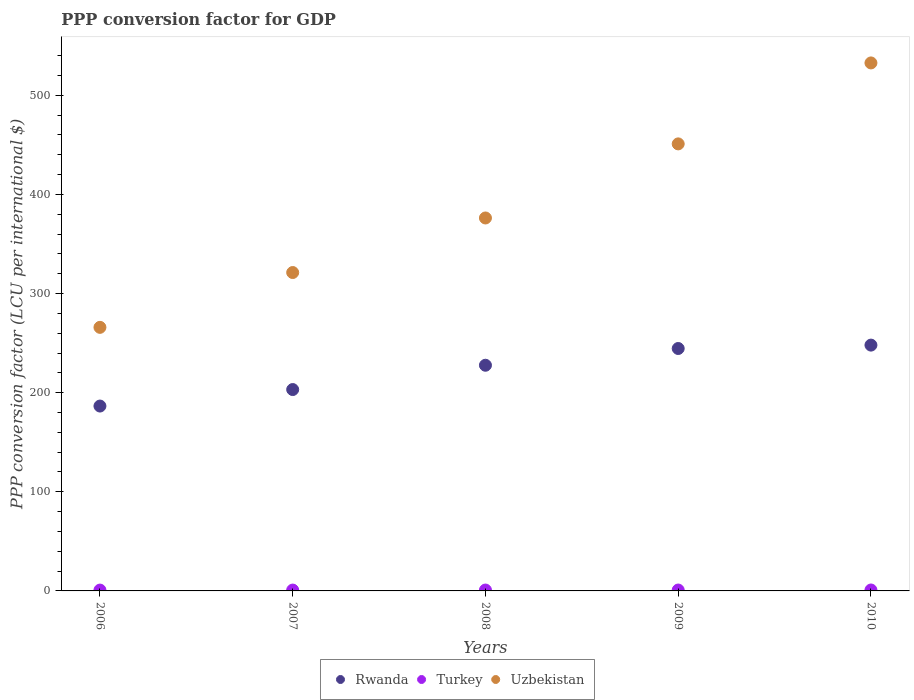How many different coloured dotlines are there?
Your answer should be compact. 3. What is the PPP conversion factor for GDP in Uzbekistan in 2007?
Keep it short and to the point. 321.22. Across all years, what is the maximum PPP conversion factor for GDP in Rwanda?
Keep it short and to the point. 248. Across all years, what is the minimum PPP conversion factor for GDP in Rwanda?
Ensure brevity in your answer.  186.52. In which year was the PPP conversion factor for GDP in Uzbekistan minimum?
Keep it short and to the point. 2006. What is the total PPP conversion factor for GDP in Turkey in the graph?
Make the answer very short. 4.45. What is the difference between the PPP conversion factor for GDP in Uzbekistan in 2007 and that in 2010?
Keep it short and to the point. -211.46. What is the difference between the PPP conversion factor for GDP in Uzbekistan in 2007 and the PPP conversion factor for GDP in Turkey in 2009?
Your answer should be very brief. 320.31. What is the average PPP conversion factor for GDP in Rwanda per year?
Offer a terse response. 221.99. In the year 2010, what is the difference between the PPP conversion factor for GDP in Rwanda and PPP conversion factor for GDP in Uzbekistan?
Your answer should be very brief. -284.69. What is the ratio of the PPP conversion factor for GDP in Rwanda in 2006 to that in 2008?
Offer a terse response. 0.82. Is the PPP conversion factor for GDP in Uzbekistan in 2006 less than that in 2008?
Your response must be concise. Yes. Is the difference between the PPP conversion factor for GDP in Rwanda in 2006 and 2008 greater than the difference between the PPP conversion factor for GDP in Uzbekistan in 2006 and 2008?
Provide a succinct answer. Yes. What is the difference between the highest and the second highest PPP conversion factor for GDP in Rwanda?
Your response must be concise. 3.42. What is the difference between the highest and the lowest PPP conversion factor for GDP in Uzbekistan?
Provide a succinct answer. 266.77. In how many years, is the PPP conversion factor for GDP in Turkey greater than the average PPP conversion factor for GDP in Turkey taken over all years?
Offer a terse response. 2. Is the PPP conversion factor for GDP in Uzbekistan strictly less than the PPP conversion factor for GDP in Turkey over the years?
Make the answer very short. No. How many dotlines are there?
Provide a succinct answer. 3. Are the values on the major ticks of Y-axis written in scientific E-notation?
Your answer should be very brief. No. Does the graph contain grids?
Your answer should be very brief. No. Where does the legend appear in the graph?
Provide a succinct answer. Bottom center. How many legend labels are there?
Your response must be concise. 3. How are the legend labels stacked?
Offer a very short reply. Horizontal. What is the title of the graph?
Your response must be concise. PPP conversion factor for GDP. What is the label or title of the X-axis?
Provide a short and direct response. Years. What is the label or title of the Y-axis?
Your answer should be compact. PPP conversion factor (LCU per international $). What is the PPP conversion factor (LCU per international $) of Rwanda in 2006?
Provide a succinct answer. 186.52. What is the PPP conversion factor (LCU per international $) of Turkey in 2006?
Make the answer very short. 0.85. What is the PPP conversion factor (LCU per international $) in Uzbekistan in 2006?
Your answer should be compact. 265.92. What is the PPP conversion factor (LCU per international $) in Rwanda in 2007?
Keep it short and to the point. 203.16. What is the PPP conversion factor (LCU per international $) of Turkey in 2007?
Offer a terse response. 0.86. What is the PPP conversion factor (LCU per international $) in Uzbekistan in 2007?
Offer a terse response. 321.22. What is the PPP conversion factor (LCU per international $) of Rwanda in 2008?
Your answer should be very brief. 227.68. What is the PPP conversion factor (LCU per international $) in Turkey in 2008?
Offer a terse response. 0.89. What is the PPP conversion factor (LCU per international $) in Uzbekistan in 2008?
Give a very brief answer. 376.27. What is the PPP conversion factor (LCU per international $) of Rwanda in 2009?
Provide a succinct answer. 244.58. What is the PPP conversion factor (LCU per international $) of Turkey in 2009?
Offer a terse response. 0.91. What is the PPP conversion factor (LCU per international $) of Uzbekistan in 2009?
Provide a short and direct response. 451.01. What is the PPP conversion factor (LCU per international $) of Rwanda in 2010?
Your answer should be compact. 248. What is the PPP conversion factor (LCU per international $) of Turkey in 2010?
Make the answer very short. 0.94. What is the PPP conversion factor (LCU per international $) in Uzbekistan in 2010?
Give a very brief answer. 532.69. Across all years, what is the maximum PPP conversion factor (LCU per international $) of Rwanda?
Offer a terse response. 248. Across all years, what is the maximum PPP conversion factor (LCU per international $) of Turkey?
Provide a short and direct response. 0.94. Across all years, what is the maximum PPP conversion factor (LCU per international $) of Uzbekistan?
Your answer should be very brief. 532.69. Across all years, what is the minimum PPP conversion factor (LCU per international $) of Rwanda?
Make the answer very short. 186.52. Across all years, what is the minimum PPP conversion factor (LCU per international $) in Turkey?
Give a very brief answer. 0.85. Across all years, what is the minimum PPP conversion factor (LCU per international $) of Uzbekistan?
Give a very brief answer. 265.92. What is the total PPP conversion factor (LCU per international $) of Rwanda in the graph?
Make the answer very short. 1109.94. What is the total PPP conversion factor (LCU per international $) in Turkey in the graph?
Provide a succinct answer. 4.45. What is the total PPP conversion factor (LCU per international $) of Uzbekistan in the graph?
Ensure brevity in your answer.  1947.11. What is the difference between the PPP conversion factor (LCU per international $) in Rwanda in 2006 and that in 2007?
Ensure brevity in your answer.  -16.65. What is the difference between the PPP conversion factor (LCU per international $) of Turkey in 2006 and that in 2007?
Keep it short and to the point. -0.02. What is the difference between the PPP conversion factor (LCU per international $) of Uzbekistan in 2006 and that in 2007?
Make the answer very short. -55.31. What is the difference between the PPP conversion factor (LCU per international $) in Rwanda in 2006 and that in 2008?
Your response must be concise. -41.17. What is the difference between the PPP conversion factor (LCU per international $) in Turkey in 2006 and that in 2008?
Offer a very short reply. -0.04. What is the difference between the PPP conversion factor (LCU per international $) in Uzbekistan in 2006 and that in 2008?
Your response must be concise. -110.35. What is the difference between the PPP conversion factor (LCU per international $) of Rwanda in 2006 and that in 2009?
Make the answer very short. -58.06. What is the difference between the PPP conversion factor (LCU per international $) in Turkey in 2006 and that in 2009?
Your response must be concise. -0.07. What is the difference between the PPP conversion factor (LCU per international $) in Uzbekistan in 2006 and that in 2009?
Your response must be concise. -185.1. What is the difference between the PPP conversion factor (LCU per international $) in Rwanda in 2006 and that in 2010?
Provide a short and direct response. -61.48. What is the difference between the PPP conversion factor (LCU per international $) in Turkey in 2006 and that in 2010?
Your response must be concise. -0.09. What is the difference between the PPP conversion factor (LCU per international $) of Uzbekistan in 2006 and that in 2010?
Offer a terse response. -266.77. What is the difference between the PPP conversion factor (LCU per international $) in Rwanda in 2007 and that in 2008?
Your answer should be very brief. -24.52. What is the difference between the PPP conversion factor (LCU per international $) in Turkey in 2007 and that in 2008?
Offer a very short reply. -0.03. What is the difference between the PPP conversion factor (LCU per international $) in Uzbekistan in 2007 and that in 2008?
Provide a short and direct response. -55.04. What is the difference between the PPP conversion factor (LCU per international $) of Rwanda in 2007 and that in 2009?
Provide a short and direct response. -41.41. What is the difference between the PPP conversion factor (LCU per international $) in Turkey in 2007 and that in 2009?
Your answer should be very brief. -0.05. What is the difference between the PPP conversion factor (LCU per international $) in Uzbekistan in 2007 and that in 2009?
Offer a terse response. -129.79. What is the difference between the PPP conversion factor (LCU per international $) in Rwanda in 2007 and that in 2010?
Give a very brief answer. -44.84. What is the difference between the PPP conversion factor (LCU per international $) in Turkey in 2007 and that in 2010?
Your response must be concise. -0.08. What is the difference between the PPP conversion factor (LCU per international $) in Uzbekistan in 2007 and that in 2010?
Offer a very short reply. -211.46. What is the difference between the PPP conversion factor (LCU per international $) in Rwanda in 2008 and that in 2009?
Ensure brevity in your answer.  -16.9. What is the difference between the PPP conversion factor (LCU per international $) of Turkey in 2008 and that in 2009?
Your response must be concise. -0.02. What is the difference between the PPP conversion factor (LCU per international $) of Uzbekistan in 2008 and that in 2009?
Your response must be concise. -74.75. What is the difference between the PPP conversion factor (LCU per international $) of Rwanda in 2008 and that in 2010?
Give a very brief answer. -20.32. What is the difference between the PPP conversion factor (LCU per international $) of Turkey in 2008 and that in 2010?
Your answer should be very brief. -0.05. What is the difference between the PPP conversion factor (LCU per international $) in Uzbekistan in 2008 and that in 2010?
Keep it short and to the point. -156.42. What is the difference between the PPP conversion factor (LCU per international $) in Rwanda in 2009 and that in 2010?
Offer a very short reply. -3.42. What is the difference between the PPP conversion factor (LCU per international $) in Turkey in 2009 and that in 2010?
Offer a very short reply. -0.03. What is the difference between the PPP conversion factor (LCU per international $) in Uzbekistan in 2009 and that in 2010?
Make the answer very short. -81.67. What is the difference between the PPP conversion factor (LCU per international $) of Rwanda in 2006 and the PPP conversion factor (LCU per international $) of Turkey in 2007?
Make the answer very short. 185.65. What is the difference between the PPP conversion factor (LCU per international $) in Rwanda in 2006 and the PPP conversion factor (LCU per international $) in Uzbekistan in 2007?
Offer a terse response. -134.71. What is the difference between the PPP conversion factor (LCU per international $) of Turkey in 2006 and the PPP conversion factor (LCU per international $) of Uzbekistan in 2007?
Ensure brevity in your answer.  -320.38. What is the difference between the PPP conversion factor (LCU per international $) in Rwanda in 2006 and the PPP conversion factor (LCU per international $) in Turkey in 2008?
Offer a terse response. 185.63. What is the difference between the PPP conversion factor (LCU per international $) of Rwanda in 2006 and the PPP conversion factor (LCU per international $) of Uzbekistan in 2008?
Make the answer very short. -189.75. What is the difference between the PPP conversion factor (LCU per international $) in Turkey in 2006 and the PPP conversion factor (LCU per international $) in Uzbekistan in 2008?
Your answer should be very brief. -375.42. What is the difference between the PPP conversion factor (LCU per international $) of Rwanda in 2006 and the PPP conversion factor (LCU per international $) of Turkey in 2009?
Make the answer very short. 185.6. What is the difference between the PPP conversion factor (LCU per international $) of Rwanda in 2006 and the PPP conversion factor (LCU per international $) of Uzbekistan in 2009?
Offer a very short reply. -264.5. What is the difference between the PPP conversion factor (LCU per international $) of Turkey in 2006 and the PPP conversion factor (LCU per international $) of Uzbekistan in 2009?
Provide a short and direct response. -450.17. What is the difference between the PPP conversion factor (LCU per international $) in Rwanda in 2006 and the PPP conversion factor (LCU per international $) in Turkey in 2010?
Offer a terse response. 185.57. What is the difference between the PPP conversion factor (LCU per international $) in Rwanda in 2006 and the PPP conversion factor (LCU per international $) in Uzbekistan in 2010?
Your answer should be compact. -346.17. What is the difference between the PPP conversion factor (LCU per international $) of Turkey in 2006 and the PPP conversion factor (LCU per international $) of Uzbekistan in 2010?
Ensure brevity in your answer.  -531.84. What is the difference between the PPP conversion factor (LCU per international $) of Rwanda in 2007 and the PPP conversion factor (LCU per international $) of Turkey in 2008?
Provide a short and direct response. 202.27. What is the difference between the PPP conversion factor (LCU per international $) of Rwanda in 2007 and the PPP conversion factor (LCU per international $) of Uzbekistan in 2008?
Offer a terse response. -173.1. What is the difference between the PPP conversion factor (LCU per international $) of Turkey in 2007 and the PPP conversion factor (LCU per international $) of Uzbekistan in 2008?
Your answer should be compact. -375.4. What is the difference between the PPP conversion factor (LCU per international $) in Rwanda in 2007 and the PPP conversion factor (LCU per international $) in Turkey in 2009?
Offer a very short reply. 202.25. What is the difference between the PPP conversion factor (LCU per international $) of Rwanda in 2007 and the PPP conversion factor (LCU per international $) of Uzbekistan in 2009?
Keep it short and to the point. -247.85. What is the difference between the PPP conversion factor (LCU per international $) in Turkey in 2007 and the PPP conversion factor (LCU per international $) in Uzbekistan in 2009?
Your answer should be very brief. -450.15. What is the difference between the PPP conversion factor (LCU per international $) in Rwanda in 2007 and the PPP conversion factor (LCU per international $) in Turkey in 2010?
Offer a very short reply. 202.22. What is the difference between the PPP conversion factor (LCU per international $) of Rwanda in 2007 and the PPP conversion factor (LCU per international $) of Uzbekistan in 2010?
Offer a very short reply. -329.52. What is the difference between the PPP conversion factor (LCU per international $) in Turkey in 2007 and the PPP conversion factor (LCU per international $) in Uzbekistan in 2010?
Give a very brief answer. -531.82. What is the difference between the PPP conversion factor (LCU per international $) of Rwanda in 2008 and the PPP conversion factor (LCU per international $) of Turkey in 2009?
Give a very brief answer. 226.77. What is the difference between the PPP conversion factor (LCU per international $) in Rwanda in 2008 and the PPP conversion factor (LCU per international $) in Uzbekistan in 2009?
Give a very brief answer. -223.33. What is the difference between the PPP conversion factor (LCU per international $) of Turkey in 2008 and the PPP conversion factor (LCU per international $) of Uzbekistan in 2009?
Provide a short and direct response. -450.12. What is the difference between the PPP conversion factor (LCU per international $) of Rwanda in 2008 and the PPP conversion factor (LCU per international $) of Turkey in 2010?
Your response must be concise. 226.74. What is the difference between the PPP conversion factor (LCU per international $) in Rwanda in 2008 and the PPP conversion factor (LCU per international $) in Uzbekistan in 2010?
Make the answer very short. -305.01. What is the difference between the PPP conversion factor (LCU per international $) in Turkey in 2008 and the PPP conversion factor (LCU per international $) in Uzbekistan in 2010?
Your response must be concise. -531.8. What is the difference between the PPP conversion factor (LCU per international $) of Rwanda in 2009 and the PPP conversion factor (LCU per international $) of Turkey in 2010?
Your answer should be very brief. 243.64. What is the difference between the PPP conversion factor (LCU per international $) in Rwanda in 2009 and the PPP conversion factor (LCU per international $) in Uzbekistan in 2010?
Offer a terse response. -288.11. What is the difference between the PPP conversion factor (LCU per international $) in Turkey in 2009 and the PPP conversion factor (LCU per international $) in Uzbekistan in 2010?
Your answer should be compact. -531.78. What is the average PPP conversion factor (LCU per international $) of Rwanda per year?
Make the answer very short. 221.99. What is the average PPP conversion factor (LCU per international $) in Turkey per year?
Offer a very short reply. 0.89. What is the average PPP conversion factor (LCU per international $) in Uzbekistan per year?
Keep it short and to the point. 389.42. In the year 2006, what is the difference between the PPP conversion factor (LCU per international $) of Rwanda and PPP conversion factor (LCU per international $) of Turkey?
Offer a terse response. 185.67. In the year 2006, what is the difference between the PPP conversion factor (LCU per international $) of Rwanda and PPP conversion factor (LCU per international $) of Uzbekistan?
Keep it short and to the point. -79.4. In the year 2006, what is the difference between the PPP conversion factor (LCU per international $) of Turkey and PPP conversion factor (LCU per international $) of Uzbekistan?
Offer a terse response. -265.07. In the year 2007, what is the difference between the PPP conversion factor (LCU per international $) in Rwanda and PPP conversion factor (LCU per international $) in Turkey?
Your answer should be very brief. 202.3. In the year 2007, what is the difference between the PPP conversion factor (LCU per international $) in Rwanda and PPP conversion factor (LCU per international $) in Uzbekistan?
Give a very brief answer. -118.06. In the year 2007, what is the difference between the PPP conversion factor (LCU per international $) of Turkey and PPP conversion factor (LCU per international $) of Uzbekistan?
Your answer should be very brief. -320.36. In the year 2008, what is the difference between the PPP conversion factor (LCU per international $) of Rwanda and PPP conversion factor (LCU per international $) of Turkey?
Ensure brevity in your answer.  226.79. In the year 2008, what is the difference between the PPP conversion factor (LCU per international $) of Rwanda and PPP conversion factor (LCU per international $) of Uzbekistan?
Provide a short and direct response. -148.58. In the year 2008, what is the difference between the PPP conversion factor (LCU per international $) of Turkey and PPP conversion factor (LCU per international $) of Uzbekistan?
Your answer should be compact. -375.38. In the year 2009, what is the difference between the PPP conversion factor (LCU per international $) of Rwanda and PPP conversion factor (LCU per international $) of Turkey?
Provide a short and direct response. 243.67. In the year 2009, what is the difference between the PPP conversion factor (LCU per international $) of Rwanda and PPP conversion factor (LCU per international $) of Uzbekistan?
Your answer should be very brief. -206.44. In the year 2009, what is the difference between the PPP conversion factor (LCU per international $) in Turkey and PPP conversion factor (LCU per international $) in Uzbekistan?
Your answer should be compact. -450.1. In the year 2010, what is the difference between the PPP conversion factor (LCU per international $) in Rwanda and PPP conversion factor (LCU per international $) in Turkey?
Make the answer very short. 247.06. In the year 2010, what is the difference between the PPP conversion factor (LCU per international $) in Rwanda and PPP conversion factor (LCU per international $) in Uzbekistan?
Ensure brevity in your answer.  -284.69. In the year 2010, what is the difference between the PPP conversion factor (LCU per international $) in Turkey and PPP conversion factor (LCU per international $) in Uzbekistan?
Give a very brief answer. -531.75. What is the ratio of the PPP conversion factor (LCU per international $) in Rwanda in 2006 to that in 2007?
Your answer should be compact. 0.92. What is the ratio of the PPP conversion factor (LCU per international $) of Turkey in 2006 to that in 2007?
Offer a terse response. 0.98. What is the ratio of the PPP conversion factor (LCU per international $) of Uzbekistan in 2006 to that in 2007?
Provide a short and direct response. 0.83. What is the ratio of the PPP conversion factor (LCU per international $) in Rwanda in 2006 to that in 2008?
Your answer should be very brief. 0.82. What is the ratio of the PPP conversion factor (LCU per international $) in Turkey in 2006 to that in 2008?
Give a very brief answer. 0.95. What is the ratio of the PPP conversion factor (LCU per international $) of Uzbekistan in 2006 to that in 2008?
Ensure brevity in your answer.  0.71. What is the ratio of the PPP conversion factor (LCU per international $) in Rwanda in 2006 to that in 2009?
Provide a short and direct response. 0.76. What is the ratio of the PPP conversion factor (LCU per international $) in Turkey in 2006 to that in 2009?
Your response must be concise. 0.93. What is the ratio of the PPP conversion factor (LCU per international $) in Uzbekistan in 2006 to that in 2009?
Make the answer very short. 0.59. What is the ratio of the PPP conversion factor (LCU per international $) of Rwanda in 2006 to that in 2010?
Your answer should be very brief. 0.75. What is the ratio of the PPP conversion factor (LCU per international $) of Turkey in 2006 to that in 2010?
Give a very brief answer. 0.9. What is the ratio of the PPP conversion factor (LCU per international $) of Uzbekistan in 2006 to that in 2010?
Offer a very short reply. 0.5. What is the ratio of the PPP conversion factor (LCU per international $) in Rwanda in 2007 to that in 2008?
Ensure brevity in your answer.  0.89. What is the ratio of the PPP conversion factor (LCU per international $) in Turkey in 2007 to that in 2008?
Provide a short and direct response. 0.97. What is the ratio of the PPP conversion factor (LCU per international $) of Uzbekistan in 2007 to that in 2008?
Your answer should be very brief. 0.85. What is the ratio of the PPP conversion factor (LCU per international $) of Rwanda in 2007 to that in 2009?
Provide a succinct answer. 0.83. What is the ratio of the PPP conversion factor (LCU per international $) in Turkey in 2007 to that in 2009?
Make the answer very short. 0.95. What is the ratio of the PPP conversion factor (LCU per international $) of Uzbekistan in 2007 to that in 2009?
Offer a very short reply. 0.71. What is the ratio of the PPP conversion factor (LCU per international $) in Rwanda in 2007 to that in 2010?
Keep it short and to the point. 0.82. What is the ratio of the PPP conversion factor (LCU per international $) of Turkey in 2007 to that in 2010?
Your answer should be very brief. 0.92. What is the ratio of the PPP conversion factor (LCU per international $) of Uzbekistan in 2007 to that in 2010?
Provide a short and direct response. 0.6. What is the ratio of the PPP conversion factor (LCU per international $) in Rwanda in 2008 to that in 2009?
Your response must be concise. 0.93. What is the ratio of the PPP conversion factor (LCU per international $) of Turkey in 2008 to that in 2009?
Provide a short and direct response. 0.98. What is the ratio of the PPP conversion factor (LCU per international $) of Uzbekistan in 2008 to that in 2009?
Offer a very short reply. 0.83. What is the ratio of the PPP conversion factor (LCU per international $) in Rwanda in 2008 to that in 2010?
Offer a terse response. 0.92. What is the ratio of the PPP conversion factor (LCU per international $) of Turkey in 2008 to that in 2010?
Keep it short and to the point. 0.95. What is the ratio of the PPP conversion factor (LCU per international $) of Uzbekistan in 2008 to that in 2010?
Give a very brief answer. 0.71. What is the ratio of the PPP conversion factor (LCU per international $) in Rwanda in 2009 to that in 2010?
Ensure brevity in your answer.  0.99. What is the ratio of the PPP conversion factor (LCU per international $) in Turkey in 2009 to that in 2010?
Offer a very short reply. 0.97. What is the ratio of the PPP conversion factor (LCU per international $) in Uzbekistan in 2009 to that in 2010?
Your response must be concise. 0.85. What is the difference between the highest and the second highest PPP conversion factor (LCU per international $) in Rwanda?
Provide a succinct answer. 3.42. What is the difference between the highest and the second highest PPP conversion factor (LCU per international $) in Turkey?
Your answer should be compact. 0.03. What is the difference between the highest and the second highest PPP conversion factor (LCU per international $) of Uzbekistan?
Keep it short and to the point. 81.67. What is the difference between the highest and the lowest PPP conversion factor (LCU per international $) in Rwanda?
Your answer should be very brief. 61.48. What is the difference between the highest and the lowest PPP conversion factor (LCU per international $) in Turkey?
Keep it short and to the point. 0.09. What is the difference between the highest and the lowest PPP conversion factor (LCU per international $) of Uzbekistan?
Your answer should be very brief. 266.77. 